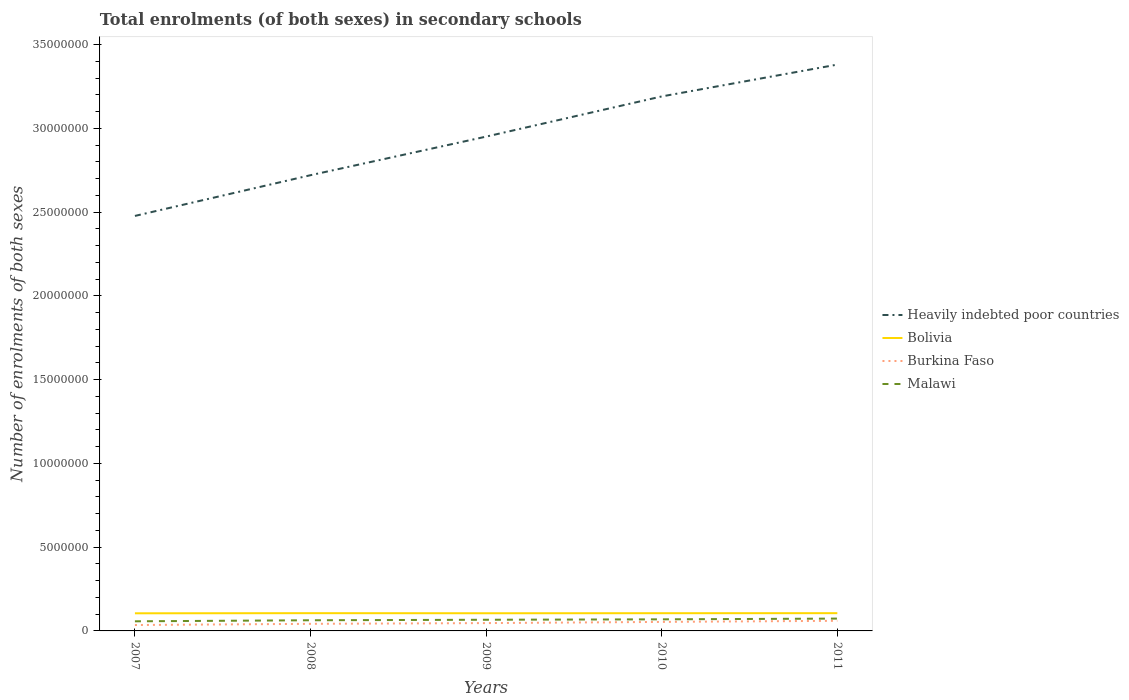How many different coloured lines are there?
Give a very brief answer. 4. Does the line corresponding to Heavily indebted poor countries intersect with the line corresponding to Burkina Faso?
Your answer should be compact. No. Across all years, what is the maximum number of enrolments in secondary schools in Malawi?
Offer a terse response. 5.74e+05. What is the total number of enrolments in secondary schools in Heavily indebted poor countries in the graph?
Offer a terse response. -2.40e+06. What is the difference between the highest and the second highest number of enrolments in secondary schools in Malawi?
Keep it short and to the point. 1.62e+05. What is the difference between the highest and the lowest number of enrolments in secondary schools in Burkina Faso?
Offer a terse response. 2. Is the number of enrolments in secondary schools in Heavily indebted poor countries strictly greater than the number of enrolments in secondary schools in Malawi over the years?
Keep it short and to the point. No. How many lines are there?
Provide a succinct answer. 4. How many years are there in the graph?
Your answer should be very brief. 5. Are the values on the major ticks of Y-axis written in scientific E-notation?
Keep it short and to the point. No. Does the graph contain any zero values?
Give a very brief answer. No. How many legend labels are there?
Give a very brief answer. 4. What is the title of the graph?
Provide a succinct answer. Total enrolments (of both sexes) in secondary schools. Does "Hong Kong" appear as one of the legend labels in the graph?
Your response must be concise. No. What is the label or title of the Y-axis?
Keep it short and to the point. Number of enrolments of both sexes. What is the Number of enrolments of both sexes in Heavily indebted poor countries in 2007?
Your response must be concise. 2.48e+07. What is the Number of enrolments of both sexes of Bolivia in 2007?
Your response must be concise. 1.05e+06. What is the Number of enrolments of both sexes of Burkina Faso in 2007?
Offer a very short reply. 3.52e+05. What is the Number of enrolments of both sexes in Malawi in 2007?
Give a very brief answer. 5.74e+05. What is the Number of enrolments of both sexes of Heavily indebted poor countries in 2008?
Provide a succinct answer. 2.72e+07. What is the Number of enrolments of both sexes in Bolivia in 2008?
Keep it short and to the point. 1.06e+06. What is the Number of enrolments of both sexes in Burkina Faso in 2008?
Your answer should be compact. 4.24e+05. What is the Number of enrolments of both sexes of Malawi in 2008?
Offer a terse response. 6.36e+05. What is the Number of enrolments of both sexes of Heavily indebted poor countries in 2009?
Give a very brief answer. 2.95e+07. What is the Number of enrolments of both sexes of Bolivia in 2009?
Your answer should be compact. 1.05e+06. What is the Number of enrolments of both sexes in Burkina Faso in 2009?
Offer a very short reply. 4.68e+05. What is the Number of enrolments of both sexes in Malawi in 2009?
Your response must be concise. 6.67e+05. What is the Number of enrolments of both sexes of Heavily indebted poor countries in 2010?
Offer a terse response. 3.19e+07. What is the Number of enrolments of both sexes in Bolivia in 2010?
Offer a very short reply. 1.06e+06. What is the Number of enrolments of both sexes of Burkina Faso in 2010?
Provide a short and direct response. 5.38e+05. What is the Number of enrolments of both sexes of Malawi in 2010?
Make the answer very short. 6.92e+05. What is the Number of enrolments of both sexes in Heavily indebted poor countries in 2011?
Offer a very short reply. 3.38e+07. What is the Number of enrolments of both sexes of Bolivia in 2011?
Offer a terse response. 1.06e+06. What is the Number of enrolments of both sexes in Burkina Faso in 2011?
Keep it short and to the point. 6.04e+05. What is the Number of enrolments of both sexes of Malawi in 2011?
Make the answer very short. 7.36e+05. Across all years, what is the maximum Number of enrolments of both sexes of Heavily indebted poor countries?
Ensure brevity in your answer.  3.38e+07. Across all years, what is the maximum Number of enrolments of both sexes in Bolivia?
Provide a succinct answer. 1.06e+06. Across all years, what is the maximum Number of enrolments of both sexes of Burkina Faso?
Provide a succinct answer. 6.04e+05. Across all years, what is the maximum Number of enrolments of both sexes in Malawi?
Make the answer very short. 7.36e+05. Across all years, what is the minimum Number of enrolments of both sexes in Heavily indebted poor countries?
Offer a terse response. 2.48e+07. Across all years, what is the minimum Number of enrolments of both sexes in Bolivia?
Provide a succinct answer. 1.05e+06. Across all years, what is the minimum Number of enrolments of both sexes in Burkina Faso?
Provide a succinct answer. 3.52e+05. Across all years, what is the minimum Number of enrolments of both sexes of Malawi?
Ensure brevity in your answer.  5.74e+05. What is the total Number of enrolments of both sexes in Heavily indebted poor countries in the graph?
Your answer should be very brief. 1.47e+08. What is the total Number of enrolments of both sexes in Bolivia in the graph?
Offer a very short reply. 5.28e+06. What is the total Number of enrolments of both sexes of Burkina Faso in the graph?
Your answer should be compact. 2.39e+06. What is the total Number of enrolments of both sexes in Malawi in the graph?
Provide a succinct answer. 3.31e+06. What is the difference between the Number of enrolments of both sexes of Heavily indebted poor countries in 2007 and that in 2008?
Keep it short and to the point. -2.43e+06. What is the difference between the Number of enrolments of both sexes of Bolivia in 2007 and that in 2008?
Your answer should be compact. -7627. What is the difference between the Number of enrolments of both sexes in Burkina Faso in 2007 and that in 2008?
Your response must be concise. -7.12e+04. What is the difference between the Number of enrolments of both sexes in Malawi in 2007 and that in 2008?
Offer a very short reply. -6.24e+04. What is the difference between the Number of enrolments of both sexes of Heavily indebted poor countries in 2007 and that in 2009?
Keep it short and to the point. -4.73e+06. What is the difference between the Number of enrolments of both sexes in Bolivia in 2007 and that in 2009?
Your answer should be compact. -2864. What is the difference between the Number of enrolments of both sexes in Burkina Faso in 2007 and that in 2009?
Keep it short and to the point. -1.15e+05. What is the difference between the Number of enrolments of both sexes of Malawi in 2007 and that in 2009?
Provide a succinct answer. -9.27e+04. What is the difference between the Number of enrolments of both sexes in Heavily indebted poor countries in 2007 and that in 2010?
Ensure brevity in your answer.  -7.13e+06. What is the difference between the Number of enrolments of both sexes in Bolivia in 2007 and that in 2010?
Ensure brevity in your answer.  -6243. What is the difference between the Number of enrolments of both sexes in Burkina Faso in 2007 and that in 2010?
Offer a very short reply. -1.86e+05. What is the difference between the Number of enrolments of both sexes in Malawi in 2007 and that in 2010?
Make the answer very short. -1.18e+05. What is the difference between the Number of enrolments of both sexes in Heavily indebted poor countries in 2007 and that in 2011?
Ensure brevity in your answer.  -9.03e+06. What is the difference between the Number of enrolments of both sexes of Bolivia in 2007 and that in 2011?
Provide a short and direct response. -7966. What is the difference between the Number of enrolments of both sexes of Burkina Faso in 2007 and that in 2011?
Keep it short and to the point. -2.52e+05. What is the difference between the Number of enrolments of both sexes in Malawi in 2007 and that in 2011?
Make the answer very short. -1.62e+05. What is the difference between the Number of enrolments of both sexes of Heavily indebted poor countries in 2008 and that in 2009?
Provide a short and direct response. -2.30e+06. What is the difference between the Number of enrolments of both sexes of Bolivia in 2008 and that in 2009?
Your response must be concise. 4763. What is the difference between the Number of enrolments of both sexes in Burkina Faso in 2008 and that in 2009?
Offer a terse response. -4.41e+04. What is the difference between the Number of enrolments of both sexes of Malawi in 2008 and that in 2009?
Keep it short and to the point. -3.03e+04. What is the difference between the Number of enrolments of both sexes in Heavily indebted poor countries in 2008 and that in 2010?
Make the answer very short. -4.70e+06. What is the difference between the Number of enrolments of both sexes in Bolivia in 2008 and that in 2010?
Your answer should be compact. 1384. What is the difference between the Number of enrolments of both sexes of Burkina Faso in 2008 and that in 2010?
Keep it short and to the point. -1.14e+05. What is the difference between the Number of enrolments of both sexes in Malawi in 2008 and that in 2010?
Your answer should be very brief. -5.57e+04. What is the difference between the Number of enrolments of both sexes of Heavily indebted poor countries in 2008 and that in 2011?
Your response must be concise. -6.60e+06. What is the difference between the Number of enrolments of both sexes in Bolivia in 2008 and that in 2011?
Keep it short and to the point. -339. What is the difference between the Number of enrolments of both sexes in Burkina Faso in 2008 and that in 2011?
Your answer should be compact. -1.81e+05. What is the difference between the Number of enrolments of both sexes of Malawi in 2008 and that in 2011?
Ensure brevity in your answer.  -9.99e+04. What is the difference between the Number of enrolments of both sexes of Heavily indebted poor countries in 2009 and that in 2010?
Give a very brief answer. -2.40e+06. What is the difference between the Number of enrolments of both sexes of Bolivia in 2009 and that in 2010?
Give a very brief answer. -3379. What is the difference between the Number of enrolments of both sexes in Burkina Faso in 2009 and that in 2010?
Ensure brevity in your answer.  -7.03e+04. What is the difference between the Number of enrolments of both sexes in Malawi in 2009 and that in 2010?
Your answer should be compact. -2.55e+04. What is the difference between the Number of enrolments of both sexes of Heavily indebted poor countries in 2009 and that in 2011?
Ensure brevity in your answer.  -4.30e+06. What is the difference between the Number of enrolments of both sexes of Bolivia in 2009 and that in 2011?
Make the answer very short. -5102. What is the difference between the Number of enrolments of both sexes of Burkina Faso in 2009 and that in 2011?
Keep it short and to the point. -1.37e+05. What is the difference between the Number of enrolments of both sexes in Malawi in 2009 and that in 2011?
Offer a very short reply. -6.97e+04. What is the difference between the Number of enrolments of both sexes of Heavily indebted poor countries in 2010 and that in 2011?
Keep it short and to the point. -1.90e+06. What is the difference between the Number of enrolments of both sexes in Bolivia in 2010 and that in 2011?
Provide a short and direct response. -1723. What is the difference between the Number of enrolments of both sexes of Burkina Faso in 2010 and that in 2011?
Give a very brief answer. -6.62e+04. What is the difference between the Number of enrolments of both sexes of Malawi in 2010 and that in 2011?
Provide a succinct answer. -4.42e+04. What is the difference between the Number of enrolments of both sexes of Heavily indebted poor countries in 2007 and the Number of enrolments of both sexes of Bolivia in 2008?
Provide a short and direct response. 2.37e+07. What is the difference between the Number of enrolments of both sexes of Heavily indebted poor countries in 2007 and the Number of enrolments of both sexes of Burkina Faso in 2008?
Your answer should be very brief. 2.44e+07. What is the difference between the Number of enrolments of both sexes in Heavily indebted poor countries in 2007 and the Number of enrolments of both sexes in Malawi in 2008?
Provide a short and direct response. 2.41e+07. What is the difference between the Number of enrolments of both sexes in Bolivia in 2007 and the Number of enrolments of both sexes in Burkina Faso in 2008?
Ensure brevity in your answer.  6.28e+05. What is the difference between the Number of enrolments of both sexes in Bolivia in 2007 and the Number of enrolments of both sexes in Malawi in 2008?
Your answer should be compact. 4.16e+05. What is the difference between the Number of enrolments of both sexes in Burkina Faso in 2007 and the Number of enrolments of both sexes in Malawi in 2008?
Offer a terse response. -2.84e+05. What is the difference between the Number of enrolments of both sexes in Heavily indebted poor countries in 2007 and the Number of enrolments of both sexes in Bolivia in 2009?
Your response must be concise. 2.37e+07. What is the difference between the Number of enrolments of both sexes of Heavily indebted poor countries in 2007 and the Number of enrolments of both sexes of Burkina Faso in 2009?
Your response must be concise. 2.43e+07. What is the difference between the Number of enrolments of both sexes of Heavily indebted poor countries in 2007 and the Number of enrolments of both sexes of Malawi in 2009?
Offer a very short reply. 2.41e+07. What is the difference between the Number of enrolments of both sexes in Bolivia in 2007 and the Number of enrolments of both sexes in Burkina Faso in 2009?
Give a very brief answer. 5.84e+05. What is the difference between the Number of enrolments of both sexes in Bolivia in 2007 and the Number of enrolments of both sexes in Malawi in 2009?
Provide a short and direct response. 3.85e+05. What is the difference between the Number of enrolments of both sexes of Burkina Faso in 2007 and the Number of enrolments of both sexes of Malawi in 2009?
Your answer should be compact. -3.14e+05. What is the difference between the Number of enrolments of both sexes in Heavily indebted poor countries in 2007 and the Number of enrolments of both sexes in Bolivia in 2010?
Your answer should be compact. 2.37e+07. What is the difference between the Number of enrolments of both sexes of Heavily indebted poor countries in 2007 and the Number of enrolments of both sexes of Burkina Faso in 2010?
Make the answer very short. 2.42e+07. What is the difference between the Number of enrolments of both sexes of Heavily indebted poor countries in 2007 and the Number of enrolments of both sexes of Malawi in 2010?
Give a very brief answer. 2.41e+07. What is the difference between the Number of enrolments of both sexes of Bolivia in 2007 and the Number of enrolments of both sexes of Burkina Faso in 2010?
Provide a short and direct response. 5.14e+05. What is the difference between the Number of enrolments of both sexes in Bolivia in 2007 and the Number of enrolments of both sexes in Malawi in 2010?
Provide a short and direct response. 3.60e+05. What is the difference between the Number of enrolments of both sexes in Burkina Faso in 2007 and the Number of enrolments of both sexes in Malawi in 2010?
Your answer should be very brief. -3.40e+05. What is the difference between the Number of enrolments of both sexes of Heavily indebted poor countries in 2007 and the Number of enrolments of both sexes of Bolivia in 2011?
Offer a very short reply. 2.37e+07. What is the difference between the Number of enrolments of both sexes of Heavily indebted poor countries in 2007 and the Number of enrolments of both sexes of Burkina Faso in 2011?
Make the answer very short. 2.42e+07. What is the difference between the Number of enrolments of both sexes of Heavily indebted poor countries in 2007 and the Number of enrolments of both sexes of Malawi in 2011?
Provide a succinct answer. 2.40e+07. What is the difference between the Number of enrolments of both sexes in Bolivia in 2007 and the Number of enrolments of both sexes in Burkina Faso in 2011?
Your response must be concise. 4.48e+05. What is the difference between the Number of enrolments of both sexes in Bolivia in 2007 and the Number of enrolments of both sexes in Malawi in 2011?
Ensure brevity in your answer.  3.16e+05. What is the difference between the Number of enrolments of both sexes in Burkina Faso in 2007 and the Number of enrolments of both sexes in Malawi in 2011?
Give a very brief answer. -3.84e+05. What is the difference between the Number of enrolments of both sexes of Heavily indebted poor countries in 2008 and the Number of enrolments of both sexes of Bolivia in 2009?
Give a very brief answer. 2.62e+07. What is the difference between the Number of enrolments of both sexes of Heavily indebted poor countries in 2008 and the Number of enrolments of both sexes of Burkina Faso in 2009?
Provide a short and direct response. 2.67e+07. What is the difference between the Number of enrolments of both sexes of Heavily indebted poor countries in 2008 and the Number of enrolments of both sexes of Malawi in 2009?
Offer a terse response. 2.65e+07. What is the difference between the Number of enrolments of both sexes of Bolivia in 2008 and the Number of enrolments of both sexes of Burkina Faso in 2009?
Give a very brief answer. 5.92e+05. What is the difference between the Number of enrolments of both sexes of Bolivia in 2008 and the Number of enrolments of both sexes of Malawi in 2009?
Offer a terse response. 3.93e+05. What is the difference between the Number of enrolments of both sexes of Burkina Faso in 2008 and the Number of enrolments of both sexes of Malawi in 2009?
Offer a very short reply. -2.43e+05. What is the difference between the Number of enrolments of both sexes of Heavily indebted poor countries in 2008 and the Number of enrolments of both sexes of Bolivia in 2010?
Provide a short and direct response. 2.61e+07. What is the difference between the Number of enrolments of both sexes in Heavily indebted poor countries in 2008 and the Number of enrolments of both sexes in Burkina Faso in 2010?
Your answer should be very brief. 2.67e+07. What is the difference between the Number of enrolments of both sexes in Heavily indebted poor countries in 2008 and the Number of enrolments of both sexes in Malawi in 2010?
Offer a very short reply. 2.65e+07. What is the difference between the Number of enrolments of both sexes in Bolivia in 2008 and the Number of enrolments of both sexes in Burkina Faso in 2010?
Make the answer very short. 5.22e+05. What is the difference between the Number of enrolments of both sexes in Bolivia in 2008 and the Number of enrolments of both sexes in Malawi in 2010?
Your answer should be very brief. 3.67e+05. What is the difference between the Number of enrolments of both sexes of Burkina Faso in 2008 and the Number of enrolments of both sexes of Malawi in 2010?
Your response must be concise. -2.69e+05. What is the difference between the Number of enrolments of both sexes in Heavily indebted poor countries in 2008 and the Number of enrolments of both sexes in Bolivia in 2011?
Give a very brief answer. 2.61e+07. What is the difference between the Number of enrolments of both sexes in Heavily indebted poor countries in 2008 and the Number of enrolments of both sexes in Burkina Faso in 2011?
Keep it short and to the point. 2.66e+07. What is the difference between the Number of enrolments of both sexes in Heavily indebted poor countries in 2008 and the Number of enrolments of both sexes in Malawi in 2011?
Provide a succinct answer. 2.65e+07. What is the difference between the Number of enrolments of both sexes of Bolivia in 2008 and the Number of enrolments of both sexes of Burkina Faso in 2011?
Offer a terse response. 4.55e+05. What is the difference between the Number of enrolments of both sexes in Bolivia in 2008 and the Number of enrolments of both sexes in Malawi in 2011?
Your response must be concise. 3.23e+05. What is the difference between the Number of enrolments of both sexes of Burkina Faso in 2008 and the Number of enrolments of both sexes of Malawi in 2011?
Make the answer very short. -3.13e+05. What is the difference between the Number of enrolments of both sexes of Heavily indebted poor countries in 2009 and the Number of enrolments of both sexes of Bolivia in 2010?
Offer a terse response. 2.85e+07. What is the difference between the Number of enrolments of both sexes of Heavily indebted poor countries in 2009 and the Number of enrolments of both sexes of Burkina Faso in 2010?
Provide a short and direct response. 2.90e+07. What is the difference between the Number of enrolments of both sexes of Heavily indebted poor countries in 2009 and the Number of enrolments of both sexes of Malawi in 2010?
Offer a very short reply. 2.88e+07. What is the difference between the Number of enrolments of both sexes of Bolivia in 2009 and the Number of enrolments of both sexes of Burkina Faso in 2010?
Provide a short and direct response. 5.17e+05. What is the difference between the Number of enrolments of both sexes of Bolivia in 2009 and the Number of enrolments of both sexes of Malawi in 2010?
Make the answer very short. 3.63e+05. What is the difference between the Number of enrolments of both sexes in Burkina Faso in 2009 and the Number of enrolments of both sexes in Malawi in 2010?
Ensure brevity in your answer.  -2.24e+05. What is the difference between the Number of enrolments of both sexes of Heavily indebted poor countries in 2009 and the Number of enrolments of both sexes of Bolivia in 2011?
Your response must be concise. 2.85e+07. What is the difference between the Number of enrolments of both sexes in Heavily indebted poor countries in 2009 and the Number of enrolments of both sexes in Burkina Faso in 2011?
Offer a very short reply. 2.89e+07. What is the difference between the Number of enrolments of both sexes of Heavily indebted poor countries in 2009 and the Number of enrolments of both sexes of Malawi in 2011?
Offer a very short reply. 2.88e+07. What is the difference between the Number of enrolments of both sexes of Bolivia in 2009 and the Number of enrolments of both sexes of Burkina Faso in 2011?
Your response must be concise. 4.51e+05. What is the difference between the Number of enrolments of both sexes of Bolivia in 2009 and the Number of enrolments of both sexes of Malawi in 2011?
Provide a succinct answer. 3.19e+05. What is the difference between the Number of enrolments of both sexes of Burkina Faso in 2009 and the Number of enrolments of both sexes of Malawi in 2011?
Provide a succinct answer. -2.69e+05. What is the difference between the Number of enrolments of both sexes in Heavily indebted poor countries in 2010 and the Number of enrolments of both sexes in Bolivia in 2011?
Give a very brief answer. 3.09e+07. What is the difference between the Number of enrolments of both sexes of Heavily indebted poor countries in 2010 and the Number of enrolments of both sexes of Burkina Faso in 2011?
Offer a very short reply. 3.13e+07. What is the difference between the Number of enrolments of both sexes of Heavily indebted poor countries in 2010 and the Number of enrolments of both sexes of Malawi in 2011?
Make the answer very short. 3.12e+07. What is the difference between the Number of enrolments of both sexes of Bolivia in 2010 and the Number of enrolments of both sexes of Burkina Faso in 2011?
Your answer should be compact. 4.54e+05. What is the difference between the Number of enrolments of both sexes in Bolivia in 2010 and the Number of enrolments of both sexes in Malawi in 2011?
Your answer should be compact. 3.22e+05. What is the difference between the Number of enrolments of both sexes in Burkina Faso in 2010 and the Number of enrolments of both sexes in Malawi in 2011?
Offer a terse response. -1.98e+05. What is the average Number of enrolments of both sexes of Heavily indebted poor countries per year?
Keep it short and to the point. 2.94e+07. What is the average Number of enrolments of both sexes of Bolivia per year?
Your answer should be compact. 1.06e+06. What is the average Number of enrolments of both sexes of Burkina Faso per year?
Offer a terse response. 4.77e+05. What is the average Number of enrolments of both sexes of Malawi per year?
Provide a succinct answer. 6.61e+05. In the year 2007, what is the difference between the Number of enrolments of both sexes in Heavily indebted poor countries and Number of enrolments of both sexes in Bolivia?
Your answer should be compact. 2.37e+07. In the year 2007, what is the difference between the Number of enrolments of both sexes of Heavily indebted poor countries and Number of enrolments of both sexes of Burkina Faso?
Your response must be concise. 2.44e+07. In the year 2007, what is the difference between the Number of enrolments of both sexes of Heavily indebted poor countries and Number of enrolments of both sexes of Malawi?
Give a very brief answer. 2.42e+07. In the year 2007, what is the difference between the Number of enrolments of both sexes of Bolivia and Number of enrolments of both sexes of Burkina Faso?
Provide a succinct answer. 7.00e+05. In the year 2007, what is the difference between the Number of enrolments of both sexes of Bolivia and Number of enrolments of both sexes of Malawi?
Provide a short and direct response. 4.78e+05. In the year 2007, what is the difference between the Number of enrolments of both sexes in Burkina Faso and Number of enrolments of both sexes in Malawi?
Provide a short and direct response. -2.22e+05. In the year 2008, what is the difference between the Number of enrolments of both sexes of Heavily indebted poor countries and Number of enrolments of both sexes of Bolivia?
Provide a succinct answer. 2.61e+07. In the year 2008, what is the difference between the Number of enrolments of both sexes in Heavily indebted poor countries and Number of enrolments of both sexes in Burkina Faso?
Your response must be concise. 2.68e+07. In the year 2008, what is the difference between the Number of enrolments of both sexes in Heavily indebted poor countries and Number of enrolments of both sexes in Malawi?
Make the answer very short. 2.66e+07. In the year 2008, what is the difference between the Number of enrolments of both sexes of Bolivia and Number of enrolments of both sexes of Burkina Faso?
Provide a short and direct response. 6.36e+05. In the year 2008, what is the difference between the Number of enrolments of both sexes of Bolivia and Number of enrolments of both sexes of Malawi?
Keep it short and to the point. 4.23e+05. In the year 2008, what is the difference between the Number of enrolments of both sexes of Burkina Faso and Number of enrolments of both sexes of Malawi?
Offer a terse response. -2.13e+05. In the year 2009, what is the difference between the Number of enrolments of both sexes in Heavily indebted poor countries and Number of enrolments of both sexes in Bolivia?
Offer a terse response. 2.85e+07. In the year 2009, what is the difference between the Number of enrolments of both sexes of Heavily indebted poor countries and Number of enrolments of both sexes of Burkina Faso?
Provide a succinct answer. 2.90e+07. In the year 2009, what is the difference between the Number of enrolments of both sexes of Heavily indebted poor countries and Number of enrolments of both sexes of Malawi?
Your answer should be very brief. 2.88e+07. In the year 2009, what is the difference between the Number of enrolments of both sexes in Bolivia and Number of enrolments of both sexes in Burkina Faso?
Give a very brief answer. 5.87e+05. In the year 2009, what is the difference between the Number of enrolments of both sexes in Bolivia and Number of enrolments of both sexes in Malawi?
Make the answer very short. 3.88e+05. In the year 2009, what is the difference between the Number of enrolments of both sexes of Burkina Faso and Number of enrolments of both sexes of Malawi?
Provide a succinct answer. -1.99e+05. In the year 2010, what is the difference between the Number of enrolments of both sexes of Heavily indebted poor countries and Number of enrolments of both sexes of Bolivia?
Provide a succinct answer. 3.09e+07. In the year 2010, what is the difference between the Number of enrolments of both sexes of Heavily indebted poor countries and Number of enrolments of both sexes of Burkina Faso?
Your answer should be compact. 3.14e+07. In the year 2010, what is the difference between the Number of enrolments of both sexes of Heavily indebted poor countries and Number of enrolments of both sexes of Malawi?
Give a very brief answer. 3.12e+07. In the year 2010, what is the difference between the Number of enrolments of both sexes of Bolivia and Number of enrolments of both sexes of Burkina Faso?
Provide a short and direct response. 5.20e+05. In the year 2010, what is the difference between the Number of enrolments of both sexes in Bolivia and Number of enrolments of both sexes in Malawi?
Ensure brevity in your answer.  3.66e+05. In the year 2010, what is the difference between the Number of enrolments of both sexes in Burkina Faso and Number of enrolments of both sexes in Malawi?
Provide a succinct answer. -1.54e+05. In the year 2011, what is the difference between the Number of enrolments of both sexes in Heavily indebted poor countries and Number of enrolments of both sexes in Bolivia?
Ensure brevity in your answer.  3.28e+07. In the year 2011, what is the difference between the Number of enrolments of both sexes in Heavily indebted poor countries and Number of enrolments of both sexes in Burkina Faso?
Ensure brevity in your answer.  3.32e+07. In the year 2011, what is the difference between the Number of enrolments of both sexes of Heavily indebted poor countries and Number of enrolments of both sexes of Malawi?
Offer a terse response. 3.31e+07. In the year 2011, what is the difference between the Number of enrolments of both sexes of Bolivia and Number of enrolments of both sexes of Burkina Faso?
Give a very brief answer. 4.56e+05. In the year 2011, what is the difference between the Number of enrolments of both sexes in Bolivia and Number of enrolments of both sexes in Malawi?
Offer a terse response. 3.24e+05. In the year 2011, what is the difference between the Number of enrolments of both sexes in Burkina Faso and Number of enrolments of both sexes in Malawi?
Keep it short and to the point. -1.32e+05. What is the ratio of the Number of enrolments of both sexes in Heavily indebted poor countries in 2007 to that in 2008?
Give a very brief answer. 0.91. What is the ratio of the Number of enrolments of both sexes in Burkina Faso in 2007 to that in 2008?
Your answer should be very brief. 0.83. What is the ratio of the Number of enrolments of both sexes of Malawi in 2007 to that in 2008?
Your answer should be compact. 0.9. What is the ratio of the Number of enrolments of both sexes in Heavily indebted poor countries in 2007 to that in 2009?
Provide a succinct answer. 0.84. What is the ratio of the Number of enrolments of both sexes in Bolivia in 2007 to that in 2009?
Your answer should be very brief. 1. What is the ratio of the Number of enrolments of both sexes of Burkina Faso in 2007 to that in 2009?
Give a very brief answer. 0.75. What is the ratio of the Number of enrolments of both sexes of Malawi in 2007 to that in 2009?
Your response must be concise. 0.86. What is the ratio of the Number of enrolments of both sexes of Heavily indebted poor countries in 2007 to that in 2010?
Keep it short and to the point. 0.78. What is the ratio of the Number of enrolments of both sexes in Bolivia in 2007 to that in 2010?
Ensure brevity in your answer.  0.99. What is the ratio of the Number of enrolments of both sexes of Burkina Faso in 2007 to that in 2010?
Your response must be concise. 0.66. What is the ratio of the Number of enrolments of both sexes of Malawi in 2007 to that in 2010?
Provide a succinct answer. 0.83. What is the ratio of the Number of enrolments of both sexes of Heavily indebted poor countries in 2007 to that in 2011?
Provide a succinct answer. 0.73. What is the ratio of the Number of enrolments of both sexes in Bolivia in 2007 to that in 2011?
Give a very brief answer. 0.99. What is the ratio of the Number of enrolments of both sexes in Burkina Faso in 2007 to that in 2011?
Make the answer very short. 0.58. What is the ratio of the Number of enrolments of both sexes in Malawi in 2007 to that in 2011?
Your answer should be compact. 0.78. What is the ratio of the Number of enrolments of both sexes of Heavily indebted poor countries in 2008 to that in 2009?
Your answer should be very brief. 0.92. What is the ratio of the Number of enrolments of both sexes of Burkina Faso in 2008 to that in 2009?
Make the answer very short. 0.91. What is the ratio of the Number of enrolments of both sexes of Malawi in 2008 to that in 2009?
Your answer should be compact. 0.95. What is the ratio of the Number of enrolments of both sexes in Heavily indebted poor countries in 2008 to that in 2010?
Offer a terse response. 0.85. What is the ratio of the Number of enrolments of both sexes of Burkina Faso in 2008 to that in 2010?
Your answer should be very brief. 0.79. What is the ratio of the Number of enrolments of both sexes of Malawi in 2008 to that in 2010?
Your response must be concise. 0.92. What is the ratio of the Number of enrolments of both sexes in Heavily indebted poor countries in 2008 to that in 2011?
Offer a very short reply. 0.8. What is the ratio of the Number of enrolments of both sexes in Bolivia in 2008 to that in 2011?
Ensure brevity in your answer.  1. What is the ratio of the Number of enrolments of both sexes of Burkina Faso in 2008 to that in 2011?
Give a very brief answer. 0.7. What is the ratio of the Number of enrolments of both sexes in Malawi in 2008 to that in 2011?
Ensure brevity in your answer.  0.86. What is the ratio of the Number of enrolments of both sexes in Heavily indebted poor countries in 2009 to that in 2010?
Keep it short and to the point. 0.92. What is the ratio of the Number of enrolments of both sexes in Burkina Faso in 2009 to that in 2010?
Keep it short and to the point. 0.87. What is the ratio of the Number of enrolments of both sexes in Malawi in 2009 to that in 2010?
Your response must be concise. 0.96. What is the ratio of the Number of enrolments of both sexes in Heavily indebted poor countries in 2009 to that in 2011?
Give a very brief answer. 0.87. What is the ratio of the Number of enrolments of both sexes of Burkina Faso in 2009 to that in 2011?
Offer a very short reply. 0.77. What is the ratio of the Number of enrolments of both sexes of Malawi in 2009 to that in 2011?
Provide a succinct answer. 0.91. What is the ratio of the Number of enrolments of both sexes in Heavily indebted poor countries in 2010 to that in 2011?
Your answer should be very brief. 0.94. What is the ratio of the Number of enrolments of both sexes of Bolivia in 2010 to that in 2011?
Make the answer very short. 1. What is the ratio of the Number of enrolments of both sexes in Burkina Faso in 2010 to that in 2011?
Provide a succinct answer. 0.89. What is the ratio of the Number of enrolments of both sexes of Malawi in 2010 to that in 2011?
Give a very brief answer. 0.94. What is the difference between the highest and the second highest Number of enrolments of both sexes of Heavily indebted poor countries?
Make the answer very short. 1.90e+06. What is the difference between the highest and the second highest Number of enrolments of both sexes of Bolivia?
Your response must be concise. 339. What is the difference between the highest and the second highest Number of enrolments of both sexes of Burkina Faso?
Provide a short and direct response. 6.62e+04. What is the difference between the highest and the second highest Number of enrolments of both sexes of Malawi?
Give a very brief answer. 4.42e+04. What is the difference between the highest and the lowest Number of enrolments of both sexes of Heavily indebted poor countries?
Provide a succinct answer. 9.03e+06. What is the difference between the highest and the lowest Number of enrolments of both sexes in Bolivia?
Offer a terse response. 7966. What is the difference between the highest and the lowest Number of enrolments of both sexes of Burkina Faso?
Provide a succinct answer. 2.52e+05. What is the difference between the highest and the lowest Number of enrolments of both sexes of Malawi?
Provide a succinct answer. 1.62e+05. 